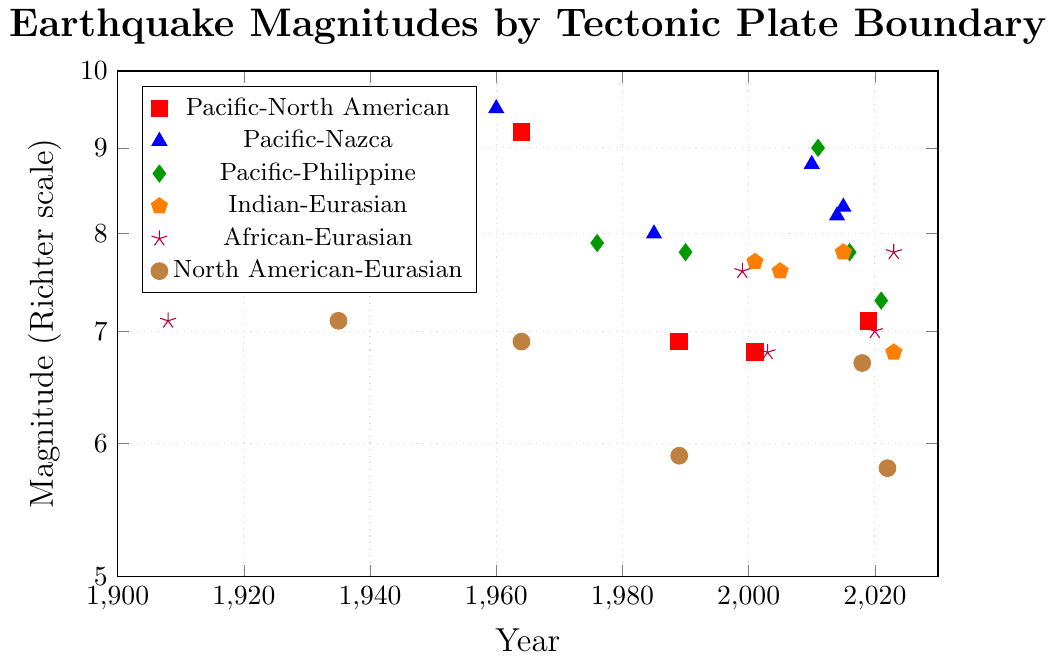Which tectonic plate boundary had the highest magnitude earthquake? The plot shows that the Pacific-Nazca boundary had the highest magnitude, with an earthquake of magnitude 9.5 in 1960.
Answer: Pacific-Nazca What is the most recent earthquake on the Pacific-Philippine boundary? According to the plot, the most recent earthquake on the Pacific-Philippine boundary occurred in 2021 with a magnitude of 7.3.
Answer: 2021 Which tectonic plate boundary has the most earthquakes above magnitude 8.0? By counting the markers above magnitude 8.0, the Pacific-Nazca boundary has the most, with five earthquakes above magnitude 8.0 (1960, 1985, 2010, 2014, and 2015).
Answer: Pacific-Nazca What is the difference in the highest magnitude earthquakes between the Pacific-North American and Indian-Eurasian boundaries? The highest magnitude earthquake on the Pacific-North American boundary is 9.2 (1964), whereas on the Indian-Eurasian boundary it is 8.6 (1950). The difference is 9.2 - 8.6 = 0.6.
Answer: 0.6 Which boundary had the earliest recorded earthquake in the plot? The plot shows that the earliest recorded earthquake occurred on the Pacific-North American boundary in 1906 with a magnitude of 7.9.
Answer: Pacific-North American How many earthquakes of magnitude 7.8 occurred on the Indian-Eurasian boundary? The plot has markers indicating earthquakes on the Indian-Eurasian boundary. There are two earthquakes with a magnitude of 7.8 (2015).
Answer: 2 Compare the magnitudes of the latest earthquakes between the North American-Eurasian and African-Eurasian boundaries in the plot. The latest earthquake on the North American-Eurasian boundary occurred in 2022 with a magnitude of 5.8, whereas on the African-Eurasian boundary it occurred in 2023 with a magnitude of 7.8.
Answer: African-Eurasian has the higher latest earthquake magnitude Which boundary has a constant number of earthquakes occurring from the 2000s onwards? The Indian-Eurasian boundary has earthquakes in 2001, 2005, 2015, and 2023, showing a consistent number of events from the list identifiable by the visual clustering of the points in the 2000s.
Answer: Indian-Eurasian 